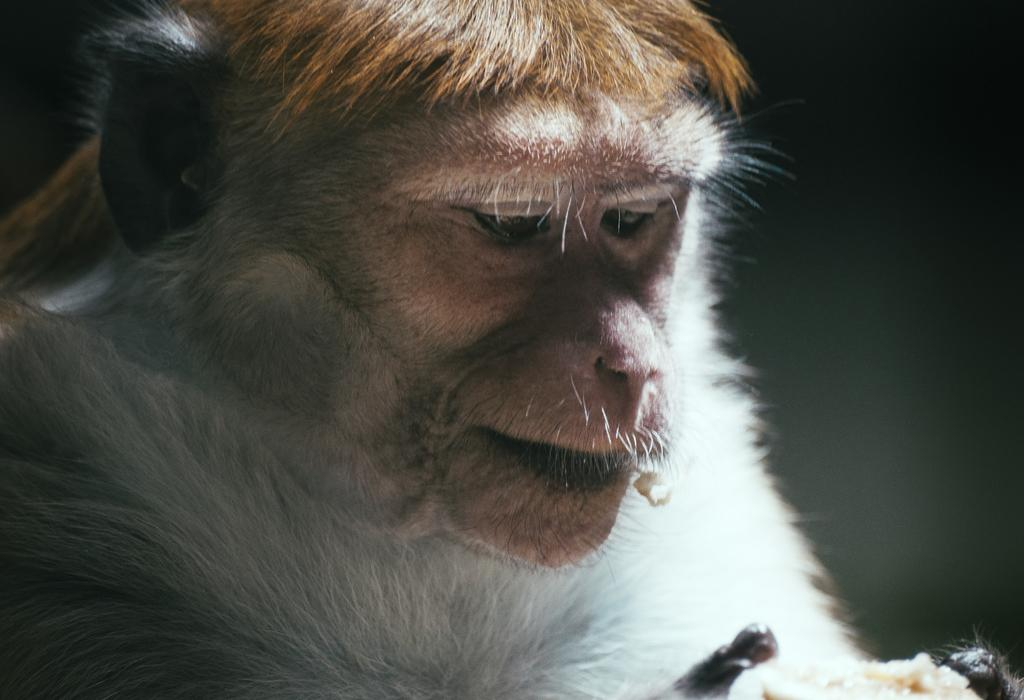What type of animal is present in the image? There is a monkey in the image. What is the monkey holding in its hand? The monkey is holding food in its hand. How many cherries can be seen on the monkey's toe in the image? There are no cherries or toes visible on the monkey in the image. What type of flock is flying in the background of the image? There is no flock present in the image; it only features a monkey holding food. 